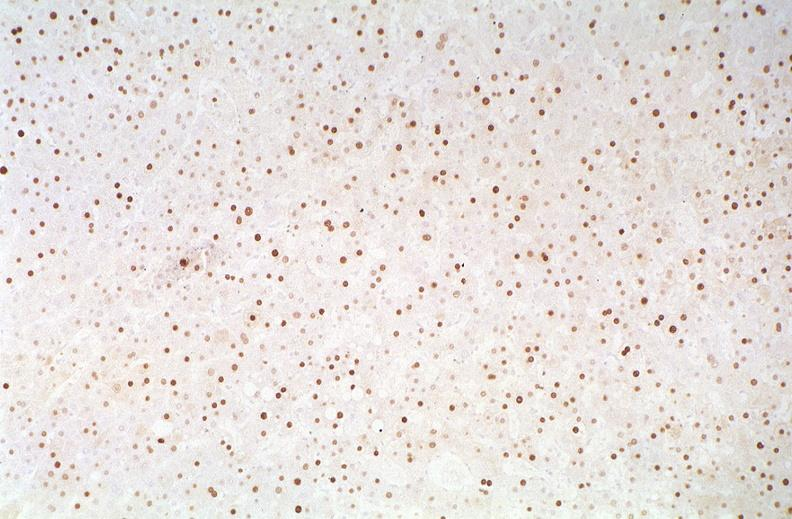what is present?
Answer the question using a single word or phrase. Liver 